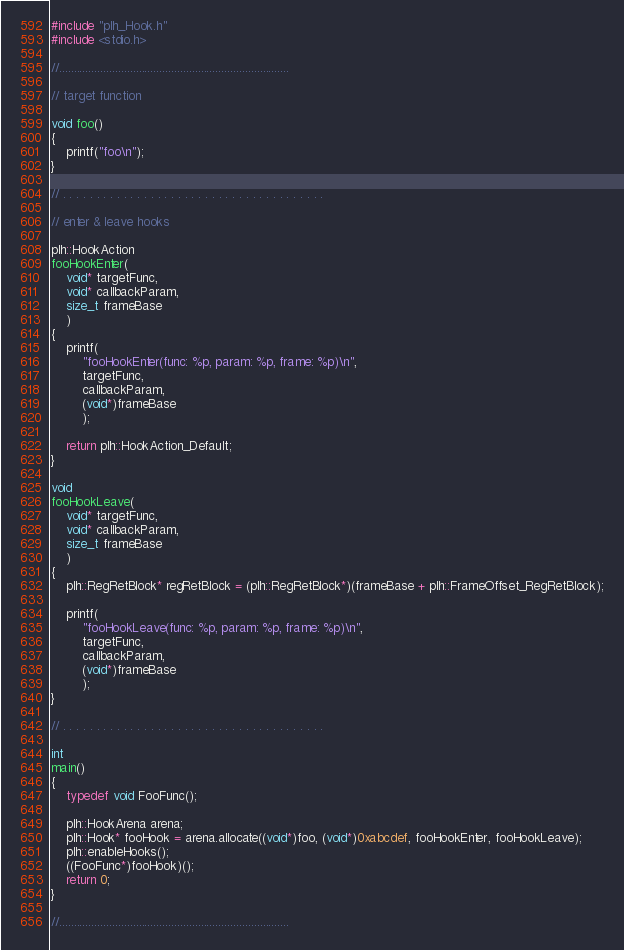Convert code to text. <code><loc_0><loc_0><loc_500><loc_500><_C++_>#include "plh_Hook.h"
#include <stdio.h>

//..............................................................................

// target function

void foo()
{
	printf("foo\n");
}

// . . . . . . . . . . . . . . . . . . . . . . . . . . . . . . . . . . . . . . .

// enter & leave hooks

plh::HookAction
fooHookEnter(
	void* targetFunc,
	void* callbackParam,
	size_t frameBase
	)
{
	printf(
		"fooHookEnter(func: %p, param: %p, frame: %p)\n",
		targetFunc,
		callbackParam,
		(void*)frameBase
		);

	return plh::HookAction_Default;
}

void
fooHookLeave(
	void* targetFunc,
	void* callbackParam,
	size_t frameBase
	)
{
	plh::RegRetBlock* regRetBlock = (plh::RegRetBlock*)(frameBase + plh::FrameOffset_RegRetBlock);

	printf(
		"fooHookLeave(func: %p, param: %p, frame: %p)\n",
		targetFunc,
		callbackParam,
		(void*)frameBase
		);
}

// . . . . . . . . . . . . . . . . . . . . . . . . . . . . . . . . . . . . . . .

int
main()
{
	typedef void FooFunc();

	plh::HookArena arena;
	plh::Hook* fooHook = arena.allocate((void*)foo, (void*)0xabcdef, fooHookEnter, fooHookLeave);
	plh::enableHooks();
	((FooFunc*)fooHook)();
	return 0;
}

//..............................................................................
</code> 